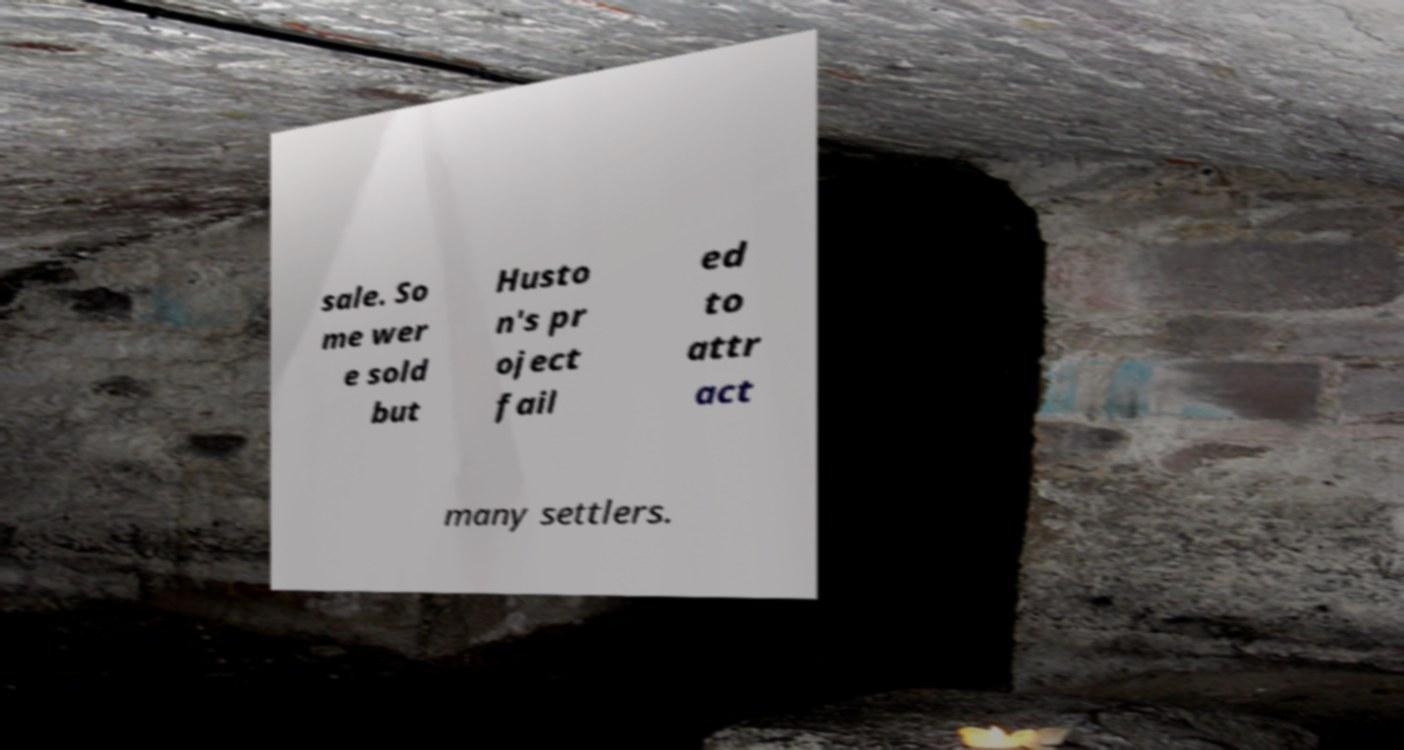There's text embedded in this image that I need extracted. Can you transcribe it verbatim? sale. So me wer e sold but Husto n's pr oject fail ed to attr act many settlers. 